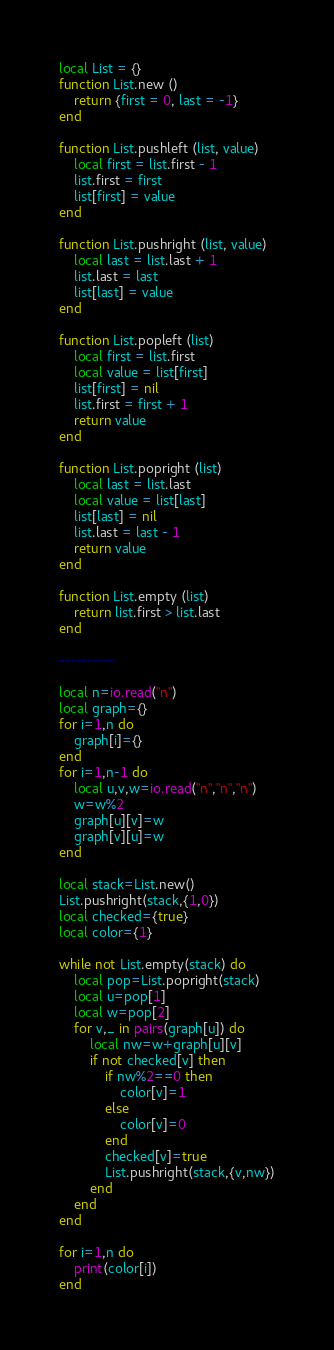<code> <loc_0><loc_0><loc_500><loc_500><_Lua_>local List = {}
function List.new ()
    return {first = 0, last = -1}
end

function List.pushleft (list, value)
    local first = list.first - 1
    list.first = first
    list[first] = value
end

function List.pushright (list, value)
    local last = list.last + 1
    list.last = last
    list[last] = value
end

function List.popleft (list)
    local first = list.first
    local value = list[first]
    list[first] = nil
    list.first = first + 1
    return value
end

function List.popright (list)
    local last = list.last
    local value = list[last]
    list[last] = nil
    list.last = last - 1
    return value
end

function List.empty (list)
    return list.first > list.last
end

----------

local n=io.read("n")
local graph={}
for i=1,n do
    graph[i]={}
end
for i=1,n-1 do
    local u,v,w=io.read("n","n","n")
    w=w%2
    graph[u][v]=w
    graph[v][u]=w
end

local stack=List.new()
List.pushright(stack,{1,0})
local checked={true}
local color={1}

while not List.empty(stack) do
    local pop=List.popright(stack)
    local u=pop[1]
    local w=pop[2]
    for v,_ in pairs(graph[u]) do
        local nw=w+graph[u][v]
        if not checked[v] then
            if nw%2==0 then
                color[v]=1
            else
                color[v]=0
            end
            checked[v]=true
            List.pushright(stack,{v,nw})
        end
    end
end

for i=1,n do
    print(color[i])
end</code> 